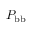Convert formula to latex. <formula><loc_0><loc_0><loc_500><loc_500>P _ { b b }</formula> 